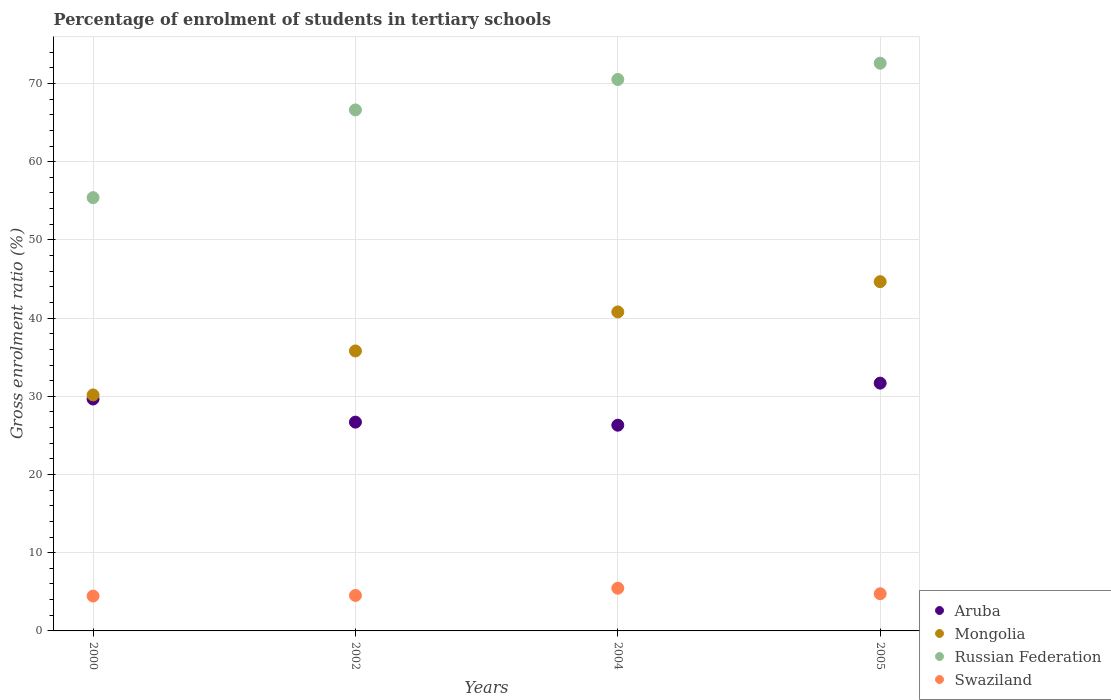How many different coloured dotlines are there?
Keep it short and to the point. 4. Is the number of dotlines equal to the number of legend labels?
Provide a short and direct response. Yes. What is the percentage of students enrolled in tertiary schools in Russian Federation in 2004?
Your answer should be very brief. 70.51. Across all years, what is the maximum percentage of students enrolled in tertiary schools in Mongolia?
Ensure brevity in your answer.  44.66. Across all years, what is the minimum percentage of students enrolled in tertiary schools in Aruba?
Keep it short and to the point. 26.3. What is the total percentage of students enrolled in tertiary schools in Mongolia in the graph?
Make the answer very short. 151.42. What is the difference between the percentage of students enrolled in tertiary schools in Swaziland in 2000 and that in 2002?
Your response must be concise. -0.08. What is the difference between the percentage of students enrolled in tertiary schools in Russian Federation in 2002 and the percentage of students enrolled in tertiary schools in Mongolia in 2000?
Your answer should be very brief. 36.44. What is the average percentage of students enrolled in tertiary schools in Russian Federation per year?
Your response must be concise. 66.28. In the year 2004, what is the difference between the percentage of students enrolled in tertiary schools in Mongolia and percentage of students enrolled in tertiary schools in Aruba?
Provide a short and direct response. 14.48. What is the ratio of the percentage of students enrolled in tertiary schools in Russian Federation in 2000 to that in 2005?
Your answer should be compact. 0.76. Is the percentage of students enrolled in tertiary schools in Swaziland in 2004 less than that in 2005?
Provide a short and direct response. No. Is the difference between the percentage of students enrolled in tertiary schools in Mongolia in 2002 and 2004 greater than the difference between the percentage of students enrolled in tertiary schools in Aruba in 2002 and 2004?
Offer a very short reply. No. What is the difference between the highest and the second highest percentage of students enrolled in tertiary schools in Aruba?
Your answer should be compact. 2.03. What is the difference between the highest and the lowest percentage of students enrolled in tertiary schools in Mongolia?
Provide a short and direct response. 14.48. In how many years, is the percentage of students enrolled in tertiary schools in Mongolia greater than the average percentage of students enrolled in tertiary schools in Mongolia taken over all years?
Ensure brevity in your answer.  2. Is the sum of the percentage of students enrolled in tertiary schools in Aruba in 2000 and 2002 greater than the maximum percentage of students enrolled in tertiary schools in Swaziland across all years?
Give a very brief answer. Yes. Is it the case that in every year, the sum of the percentage of students enrolled in tertiary schools in Mongolia and percentage of students enrolled in tertiary schools in Russian Federation  is greater than the percentage of students enrolled in tertiary schools in Aruba?
Your response must be concise. Yes. Is the percentage of students enrolled in tertiary schools in Swaziland strictly greater than the percentage of students enrolled in tertiary schools in Russian Federation over the years?
Offer a terse response. No. How many dotlines are there?
Provide a succinct answer. 4. Are the values on the major ticks of Y-axis written in scientific E-notation?
Your response must be concise. No. Does the graph contain grids?
Offer a terse response. Yes. How are the legend labels stacked?
Your answer should be compact. Vertical. What is the title of the graph?
Provide a succinct answer. Percentage of enrolment of students in tertiary schools. Does "St. Vincent and the Grenadines" appear as one of the legend labels in the graph?
Offer a very short reply. No. What is the label or title of the Y-axis?
Provide a succinct answer. Gross enrolment ratio (%). What is the Gross enrolment ratio (%) in Aruba in 2000?
Keep it short and to the point. 29.66. What is the Gross enrolment ratio (%) of Mongolia in 2000?
Offer a terse response. 30.18. What is the Gross enrolment ratio (%) of Russian Federation in 2000?
Your answer should be very brief. 55.4. What is the Gross enrolment ratio (%) of Swaziland in 2000?
Make the answer very short. 4.46. What is the Gross enrolment ratio (%) in Aruba in 2002?
Provide a short and direct response. 26.7. What is the Gross enrolment ratio (%) of Mongolia in 2002?
Offer a terse response. 35.8. What is the Gross enrolment ratio (%) of Russian Federation in 2002?
Your answer should be very brief. 66.62. What is the Gross enrolment ratio (%) of Swaziland in 2002?
Keep it short and to the point. 4.54. What is the Gross enrolment ratio (%) in Aruba in 2004?
Provide a succinct answer. 26.3. What is the Gross enrolment ratio (%) in Mongolia in 2004?
Offer a terse response. 40.79. What is the Gross enrolment ratio (%) of Russian Federation in 2004?
Your response must be concise. 70.51. What is the Gross enrolment ratio (%) of Swaziland in 2004?
Offer a terse response. 5.46. What is the Gross enrolment ratio (%) in Aruba in 2005?
Offer a terse response. 31.68. What is the Gross enrolment ratio (%) in Mongolia in 2005?
Your answer should be very brief. 44.66. What is the Gross enrolment ratio (%) in Russian Federation in 2005?
Your answer should be compact. 72.59. What is the Gross enrolment ratio (%) in Swaziland in 2005?
Your answer should be very brief. 4.75. Across all years, what is the maximum Gross enrolment ratio (%) in Aruba?
Your answer should be very brief. 31.68. Across all years, what is the maximum Gross enrolment ratio (%) of Mongolia?
Offer a terse response. 44.66. Across all years, what is the maximum Gross enrolment ratio (%) of Russian Federation?
Make the answer very short. 72.59. Across all years, what is the maximum Gross enrolment ratio (%) in Swaziland?
Keep it short and to the point. 5.46. Across all years, what is the minimum Gross enrolment ratio (%) of Aruba?
Keep it short and to the point. 26.3. Across all years, what is the minimum Gross enrolment ratio (%) of Mongolia?
Your response must be concise. 30.18. Across all years, what is the minimum Gross enrolment ratio (%) in Russian Federation?
Ensure brevity in your answer.  55.4. Across all years, what is the minimum Gross enrolment ratio (%) in Swaziland?
Provide a succinct answer. 4.46. What is the total Gross enrolment ratio (%) in Aruba in the graph?
Your answer should be compact. 114.34. What is the total Gross enrolment ratio (%) of Mongolia in the graph?
Your answer should be compact. 151.42. What is the total Gross enrolment ratio (%) of Russian Federation in the graph?
Provide a short and direct response. 265.12. What is the total Gross enrolment ratio (%) of Swaziland in the graph?
Ensure brevity in your answer.  19.21. What is the difference between the Gross enrolment ratio (%) in Aruba in 2000 and that in 2002?
Ensure brevity in your answer.  2.96. What is the difference between the Gross enrolment ratio (%) in Mongolia in 2000 and that in 2002?
Ensure brevity in your answer.  -5.62. What is the difference between the Gross enrolment ratio (%) of Russian Federation in 2000 and that in 2002?
Offer a very short reply. -11.22. What is the difference between the Gross enrolment ratio (%) in Swaziland in 2000 and that in 2002?
Your answer should be very brief. -0.08. What is the difference between the Gross enrolment ratio (%) in Aruba in 2000 and that in 2004?
Provide a succinct answer. 3.35. What is the difference between the Gross enrolment ratio (%) of Mongolia in 2000 and that in 2004?
Provide a succinct answer. -10.61. What is the difference between the Gross enrolment ratio (%) of Russian Federation in 2000 and that in 2004?
Offer a terse response. -15.11. What is the difference between the Gross enrolment ratio (%) of Swaziland in 2000 and that in 2004?
Ensure brevity in your answer.  -1. What is the difference between the Gross enrolment ratio (%) in Aruba in 2000 and that in 2005?
Give a very brief answer. -2.03. What is the difference between the Gross enrolment ratio (%) of Mongolia in 2000 and that in 2005?
Provide a short and direct response. -14.48. What is the difference between the Gross enrolment ratio (%) in Russian Federation in 2000 and that in 2005?
Ensure brevity in your answer.  -17.19. What is the difference between the Gross enrolment ratio (%) of Swaziland in 2000 and that in 2005?
Offer a very short reply. -0.29. What is the difference between the Gross enrolment ratio (%) of Aruba in 2002 and that in 2004?
Make the answer very short. 0.39. What is the difference between the Gross enrolment ratio (%) in Mongolia in 2002 and that in 2004?
Your answer should be very brief. -4.99. What is the difference between the Gross enrolment ratio (%) of Russian Federation in 2002 and that in 2004?
Give a very brief answer. -3.89. What is the difference between the Gross enrolment ratio (%) of Swaziland in 2002 and that in 2004?
Provide a short and direct response. -0.93. What is the difference between the Gross enrolment ratio (%) in Aruba in 2002 and that in 2005?
Keep it short and to the point. -4.99. What is the difference between the Gross enrolment ratio (%) of Mongolia in 2002 and that in 2005?
Keep it short and to the point. -8.86. What is the difference between the Gross enrolment ratio (%) in Russian Federation in 2002 and that in 2005?
Offer a terse response. -5.97. What is the difference between the Gross enrolment ratio (%) of Swaziland in 2002 and that in 2005?
Offer a terse response. -0.22. What is the difference between the Gross enrolment ratio (%) of Aruba in 2004 and that in 2005?
Ensure brevity in your answer.  -5.38. What is the difference between the Gross enrolment ratio (%) of Mongolia in 2004 and that in 2005?
Your answer should be compact. -3.87. What is the difference between the Gross enrolment ratio (%) of Russian Federation in 2004 and that in 2005?
Provide a short and direct response. -2.08. What is the difference between the Gross enrolment ratio (%) of Swaziland in 2004 and that in 2005?
Provide a succinct answer. 0.71. What is the difference between the Gross enrolment ratio (%) of Aruba in 2000 and the Gross enrolment ratio (%) of Mongolia in 2002?
Ensure brevity in your answer.  -6.14. What is the difference between the Gross enrolment ratio (%) in Aruba in 2000 and the Gross enrolment ratio (%) in Russian Federation in 2002?
Offer a terse response. -36.96. What is the difference between the Gross enrolment ratio (%) of Aruba in 2000 and the Gross enrolment ratio (%) of Swaziland in 2002?
Your response must be concise. 25.12. What is the difference between the Gross enrolment ratio (%) in Mongolia in 2000 and the Gross enrolment ratio (%) in Russian Federation in 2002?
Offer a very short reply. -36.44. What is the difference between the Gross enrolment ratio (%) of Mongolia in 2000 and the Gross enrolment ratio (%) of Swaziland in 2002?
Your answer should be compact. 25.64. What is the difference between the Gross enrolment ratio (%) of Russian Federation in 2000 and the Gross enrolment ratio (%) of Swaziland in 2002?
Your response must be concise. 50.87. What is the difference between the Gross enrolment ratio (%) of Aruba in 2000 and the Gross enrolment ratio (%) of Mongolia in 2004?
Offer a terse response. -11.13. What is the difference between the Gross enrolment ratio (%) in Aruba in 2000 and the Gross enrolment ratio (%) in Russian Federation in 2004?
Give a very brief answer. -40.85. What is the difference between the Gross enrolment ratio (%) of Aruba in 2000 and the Gross enrolment ratio (%) of Swaziland in 2004?
Offer a very short reply. 24.19. What is the difference between the Gross enrolment ratio (%) of Mongolia in 2000 and the Gross enrolment ratio (%) of Russian Federation in 2004?
Offer a terse response. -40.33. What is the difference between the Gross enrolment ratio (%) of Mongolia in 2000 and the Gross enrolment ratio (%) of Swaziland in 2004?
Offer a terse response. 24.72. What is the difference between the Gross enrolment ratio (%) in Russian Federation in 2000 and the Gross enrolment ratio (%) in Swaziland in 2004?
Your answer should be compact. 49.94. What is the difference between the Gross enrolment ratio (%) in Aruba in 2000 and the Gross enrolment ratio (%) in Mongolia in 2005?
Ensure brevity in your answer.  -15. What is the difference between the Gross enrolment ratio (%) in Aruba in 2000 and the Gross enrolment ratio (%) in Russian Federation in 2005?
Give a very brief answer. -42.93. What is the difference between the Gross enrolment ratio (%) of Aruba in 2000 and the Gross enrolment ratio (%) of Swaziland in 2005?
Provide a succinct answer. 24.9. What is the difference between the Gross enrolment ratio (%) in Mongolia in 2000 and the Gross enrolment ratio (%) in Russian Federation in 2005?
Offer a terse response. -42.41. What is the difference between the Gross enrolment ratio (%) in Mongolia in 2000 and the Gross enrolment ratio (%) in Swaziland in 2005?
Make the answer very short. 25.43. What is the difference between the Gross enrolment ratio (%) in Russian Federation in 2000 and the Gross enrolment ratio (%) in Swaziland in 2005?
Provide a short and direct response. 50.65. What is the difference between the Gross enrolment ratio (%) of Aruba in 2002 and the Gross enrolment ratio (%) of Mongolia in 2004?
Keep it short and to the point. -14.09. What is the difference between the Gross enrolment ratio (%) of Aruba in 2002 and the Gross enrolment ratio (%) of Russian Federation in 2004?
Provide a short and direct response. -43.81. What is the difference between the Gross enrolment ratio (%) of Aruba in 2002 and the Gross enrolment ratio (%) of Swaziland in 2004?
Provide a succinct answer. 21.24. What is the difference between the Gross enrolment ratio (%) of Mongolia in 2002 and the Gross enrolment ratio (%) of Russian Federation in 2004?
Offer a very short reply. -34.71. What is the difference between the Gross enrolment ratio (%) in Mongolia in 2002 and the Gross enrolment ratio (%) in Swaziland in 2004?
Ensure brevity in your answer.  30.34. What is the difference between the Gross enrolment ratio (%) of Russian Federation in 2002 and the Gross enrolment ratio (%) of Swaziland in 2004?
Keep it short and to the point. 61.16. What is the difference between the Gross enrolment ratio (%) of Aruba in 2002 and the Gross enrolment ratio (%) of Mongolia in 2005?
Offer a very short reply. -17.96. What is the difference between the Gross enrolment ratio (%) in Aruba in 2002 and the Gross enrolment ratio (%) in Russian Federation in 2005?
Make the answer very short. -45.89. What is the difference between the Gross enrolment ratio (%) in Aruba in 2002 and the Gross enrolment ratio (%) in Swaziland in 2005?
Ensure brevity in your answer.  21.95. What is the difference between the Gross enrolment ratio (%) of Mongolia in 2002 and the Gross enrolment ratio (%) of Russian Federation in 2005?
Make the answer very short. -36.79. What is the difference between the Gross enrolment ratio (%) in Mongolia in 2002 and the Gross enrolment ratio (%) in Swaziland in 2005?
Make the answer very short. 31.05. What is the difference between the Gross enrolment ratio (%) in Russian Federation in 2002 and the Gross enrolment ratio (%) in Swaziland in 2005?
Offer a terse response. 61.87. What is the difference between the Gross enrolment ratio (%) in Aruba in 2004 and the Gross enrolment ratio (%) in Mongolia in 2005?
Ensure brevity in your answer.  -18.35. What is the difference between the Gross enrolment ratio (%) in Aruba in 2004 and the Gross enrolment ratio (%) in Russian Federation in 2005?
Provide a short and direct response. -46.29. What is the difference between the Gross enrolment ratio (%) of Aruba in 2004 and the Gross enrolment ratio (%) of Swaziland in 2005?
Offer a terse response. 21.55. What is the difference between the Gross enrolment ratio (%) of Mongolia in 2004 and the Gross enrolment ratio (%) of Russian Federation in 2005?
Your answer should be compact. -31.8. What is the difference between the Gross enrolment ratio (%) in Mongolia in 2004 and the Gross enrolment ratio (%) in Swaziland in 2005?
Your response must be concise. 36.04. What is the difference between the Gross enrolment ratio (%) in Russian Federation in 2004 and the Gross enrolment ratio (%) in Swaziland in 2005?
Give a very brief answer. 65.76. What is the average Gross enrolment ratio (%) of Aruba per year?
Make the answer very short. 28.59. What is the average Gross enrolment ratio (%) in Mongolia per year?
Your answer should be compact. 37.86. What is the average Gross enrolment ratio (%) of Russian Federation per year?
Your answer should be compact. 66.28. What is the average Gross enrolment ratio (%) in Swaziland per year?
Offer a terse response. 4.8. In the year 2000, what is the difference between the Gross enrolment ratio (%) in Aruba and Gross enrolment ratio (%) in Mongolia?
Provide a short and direct response. -0.52. In the year 2000, what is the difference between the Gross enrolment ratio (%) of Aruba and Gross enrolment ratio (%) of Russian Federation?
Your answer should be compact. -25.75. In the year 2000, what is the difference between the Gross enrolment ratio (%) of Aruba and Gross enrolment ratio (%) of Swaziland?
Your response must be concise. 25.2. In the year 2000, what is the difference between the Gross enrolment ratio (%) in Mongolia and Gross enrolment ratio (%) in Russian Federation?
Offer a very short reply. -25.22. In the year 2000, what is the difference between the Gross enrolment ratio (%) in Mongolia and Gross enrolment ratio (%) in Swaziland?
Keep it short and to the point. 25.72. In the year 2000, what is the difference between the Gross enrolment ratio (%) in Russian Federation and Gross enrolment ratio (%) in Swaziland?
Ensure brevity in your answer.  50.94. In the year 2002, what is the difference between the Gross enrolment ratio (%) of Aruba and Gross enrolment ratio (%) of Mongolia?
Provide a short and direct response. -9.1. In the year 2002, what is the difference between the Gross enrolment ratio (%) of Aruba and Gross enrolment ratio (%) of Russian Federation?
Your answer should be compact. -39.92. In the year 2002, what is the difference between the Gross enrolment ratio (%) of Aruba and Gross enrolment ratio (%) of Swaziland?
Ensure brevity in your answer.  22.16. In the year 2002, what is the difference between the Gross enrolment ratio (%) in Mongolia and Gross enrolment ratio (%) in Russian Federation?
Your answer should be very brief. -30.82. In the year 2002, what is the difference between the Gross enrolment ratio (%) in Mongolia and Gross enrolment ratio (%) in Swaziland?
Provide a short and direct response. 31.26. In the year 2002, what is the difference between the Gross enrolment ratio (%) in Russian Federation and Gross enrolment ratio (%) in Swaziland?
Offer a very short reply. 62.08. In the year 2004, what is the difference between the Gross enrolment ratio (%) of Aruba and Gross enrolment ratio (%) of Mongolia?
Provide a short and direct response. -14.48. In the year 2004, what is the difference between the Gross enrolment ratio (%) in Aruba and Gross enrolment ratio (%) in Russian Federation?
Provide a succinct answer. -44.21. In the year 2004, what is the difference between the Gross enrolment ratio (%) of Aruba and Gross enrolment ratio (%) of Swaziland?
Your answer should be very brief. 20.84. In the year 2004, what is the difference between the Gross enrolment ratio (%) in Mongolia and Gross enrolment ratio (%) in Russian Federation?
Ensure brevity in your answer.  -29.72. In the year 2004, what is the difference between the Gross enrolment ratio (%) in Mongolia and Gross enrolment ratio (%) in Swaziland?
Your answer should be compact. 35.33. In the year 2004, what is the difference between the Gross enrolment ratio (%) in Russian Federation and Gross enrolment ratio (%) in Swaziland?
Offer a very short reply. 65.05. In the year 2005, what is the difference between the Gross enrolment ratio (%) in Aruba and Gross enrolment ratio (%) in Mongolia?
Offer a very short reply. -12.97. In the year 2005, what is the difference between the Gross enrolment ratio (%) in Aruba and Gross enrolment ratio (%) in Russian Federation?
Give a very brief answer. -40.91. In the year 2005, what is the difference between the Gross enrolment ratio (%) in Aruba and Gross enrolment ratio (%) in Swaziland?
Your response must be concise. 26.93. In the year 2005, what is the difference between the Gross enrolment ratio (%) of Mongolia and Gross enrolment ratio (%) of Russian Federation?
Provide a short and direct response. -27.93. In the year 2005, what is the difference between the Gross enrolment ratio (%) of Mongolia and Gross enrolment ratio (%) of Swaziland?
Offer a terse response. 39.91. In the year 2005, what is the difference between the Gross enrolment ratio (%) in Russian Federation and Gross enrolment ratio (%) in Swaziland?
Make the answer very short. 67.84. What is the ratio of the Gross enrolment ratio (%) in Aruba in 2000 to that in 2002?
Ensure brevity in your answer.  1.11. What is the ratio of the Gross enrolment ratio (%) in Mongolia in 2000 to that in 2002?
Your response must be concise. 0.84. What is the ratio of the Gross enrolment ratio (%) of Russian Federation in 2000 to that in 2002?
Provide a succinct answer. 0.83. What is the ratio of the Gross enrolment ratio (%) in Swaziland in 2000 to that in 2002?
Make the answer very short. 0.98. What is the ratio of the Gross enrolment ratio (%) in Aruba in 2000 to that in 2004?
Offer a terse response. 1.13. What is the ratio of the Gross enrolment ratio (%) in Mongolia in 2000 to that in 2004?
Make the answer very short. 0.74. What is the ratio of the Gross enrolment ratio (%) in Russian Federation in 2000 to that in 2004?
Provide a succinct answer. 0.79. What is the ratio of the Gross enrolment ratio (%) of Swaziland in 2000 to that in 2004?
Ensure brevity in your answer.  0.82. What is the ratio of the Gross enrolment ratio (%) in Aruba in 2000 to that in 2005?
Give a very brief answer. 0.94. What is the ratio of the Gross enrolment ratio (%) of Mongolia in 2000 to that in 2005?
Keep it short and to the point. 0.68. What is the ratio of the Gross enrolment ratio (%) in Russian Federation in 2000 to that in 2005?
Provide a short and direct response. 0.76. What is the ratio of the Gross enrolment ratio (%) in Swaziland in 2000 to that in 2005?
Provide a short and direct response. 0.94. What is the ratio of the Gross enrolment ratio (%) in Aruba in 2002 to that in 2004?
Your answer should be compact. 1.01. What is the ratio of the Gross enrolment ratio (%) in Mongolia in 2002 to that in 2004?
Your response must be concise. 0.88. What is the ratio of the Gross enrolment ratio (%) of Russian Federation in 2002 to that in 2004?
Give a very brief answer. 0.94. What is the ratio of the Gross enrolment ratio (%) in Swaziland in 2002 to that in 2004?
Make the answer very short. 0.83. What is the ratio of the Gross enrolment ratio (%) in Aruba in 2002 to that in 2005?
Provide a short and direct response. 0.84. What is the ratio of the Gross enrolment ratio (%) of Mongolia in 2002 to that in 2005?
Provide a succinct answer. 0.8. What is the ratio of the Gross enrolment ratio (%) in Russian Federation in 2002 to that in 2005?
Your response must be concise. 0.92. What is the ratio of the Gross enrolment ratio (%) of Swaziland in 2002 to that in 2005?
Your answer should be very brief. 0.95. What is the ratio of the Gross enrolment ratio (%) of Aruba in 2004 to that in 2005?
Offer a terse response. 0.83. What is the ratio of the Gross enrolment ratio (%) of Mongolia in 2004 to that in 2005?
Keep it short and to the point. 0.91. What is the ratio of the Gross enrolment ratio (%) in Russian Federation in 2004 to that in 2005?
Give a very brief answer. 0.97. What is the ratio of the Gross enrolment ratio (%) of Swaziland in 2004 to that in 2005?
Make the answer very short. 1.15. What is the difference between the highest and the second highest Gross enrolment ratio (%) in Aruba?
Provide a short and direct response. 2.03. What is the difference between the highest and the second highest Gross enrolment ratio (%) in Mongolia?
Provide a succinct answer. 3.87. What is the difference between the highest and the second highest Gross enrolment ratio (%) in Russian Federation?
Your answer should be compact. 2.08. What is the difference between the highest and the second highest Gross enrolment ratio (%) of Swaziland?
Provide a succinct answer. 0.71. What is the difference between the highest and the lowest Gross enrolment ratio (%) in Aruba?
Provide a short and direct response. 5.38. What is the difference between the highest and the lowest Gross enrolment ratio (%) of Mongolia?
Provide a short and direct response. 14.48. What is the difference between the highest and the lowest Gross enrolment ratio (%) of Russian Federation?
Make the answer very short. 17.19. 